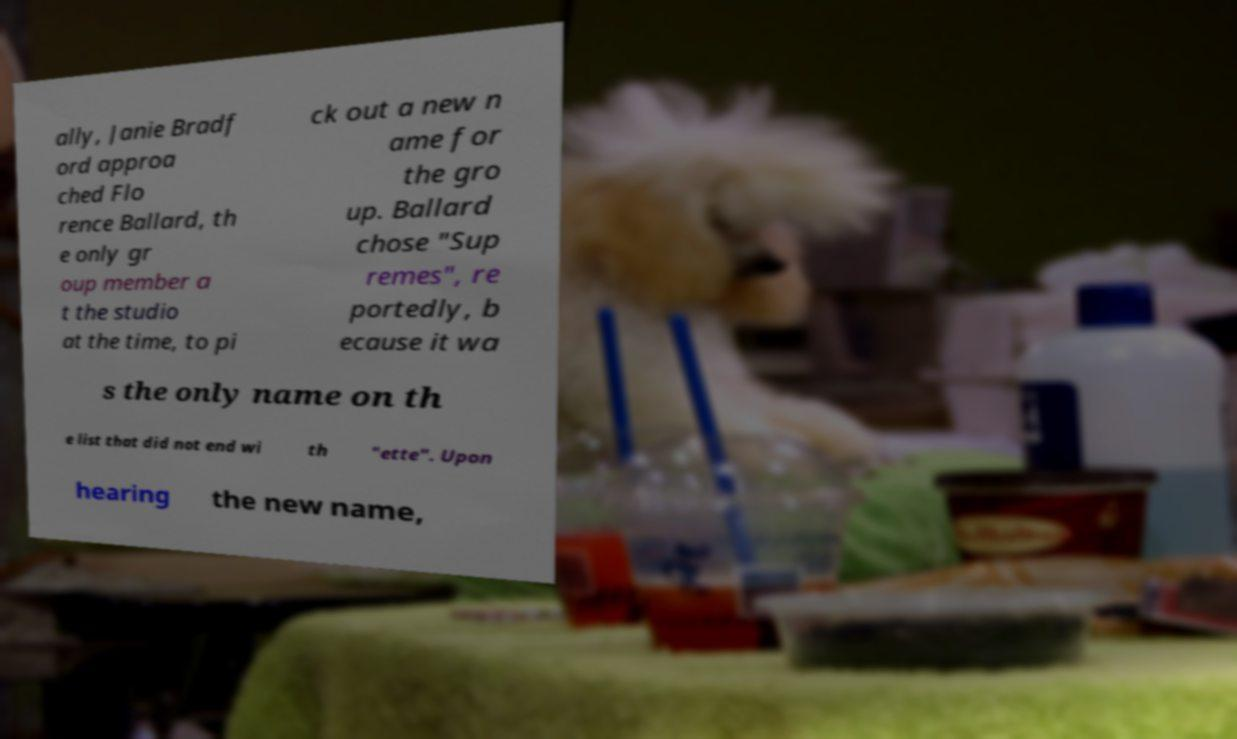Could you assist in decoding the text presented in this image and type it out clearly? ally, Janie Bradf ord approa ched Flo rence Ballard, th e only gr oup member a t the studio at the time, to pi ck out a new n ame for the gro up. Ballard chose "Sup remes", re portedly, b ecause it wa s the only name on th e list that did not end wi th "ette". Upon hearing the new name, 